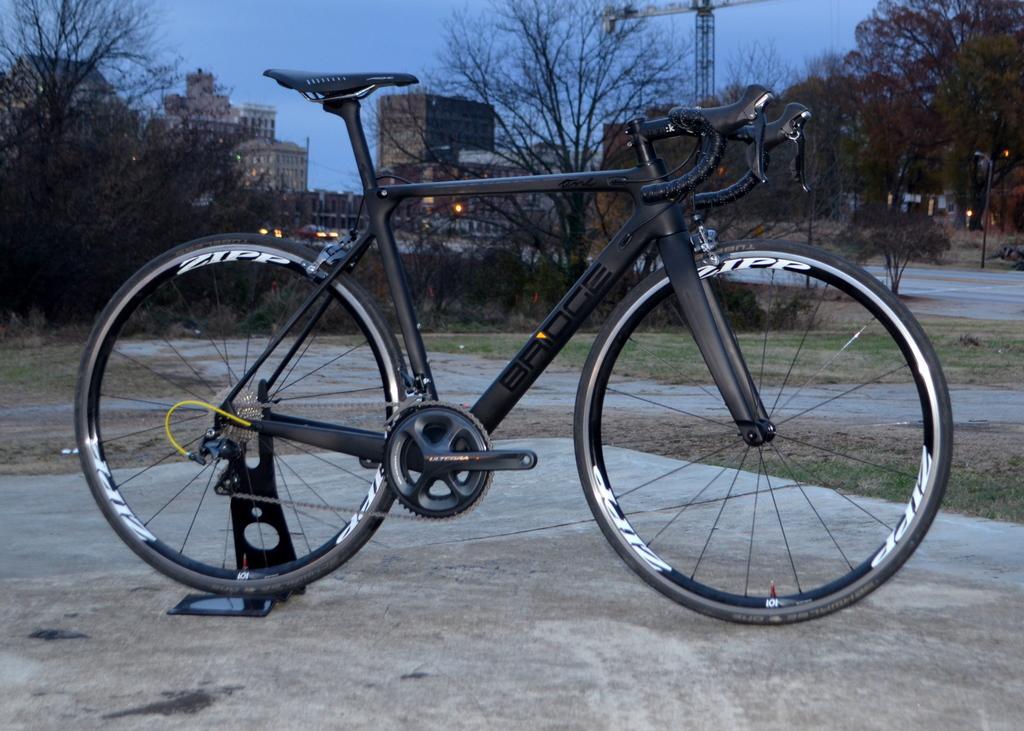How would you summarize this image in a sentence or two? In the middle of this image, there is a bicycle parked on a road. In the background, there are vehicles on a road, there are trees, buildings and there are clouds in the sky. 